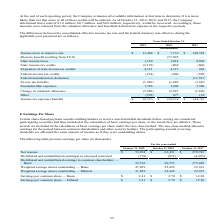From Sanderson Farms's financial document, What is the Income taxes at statutory rate for fiscal years 2019 and 2018 respectively? The document shows two values: $13,408 and $ 7,132 (in thousands). From the document: "Income taxes at statutory rate $ 13,408 $ 7,132 $ 148,585 Income taxes at statutory rate $ 13,408 $ 7,132 $ 148,585..." Also, What is the State income taxes for fiscal years 2019 and 2018 respectively? The document shows two values: 1,189 and 1,014 (in thousands). From the document: "State income taxes 1,189 1,014 9,038 State income taxes 1,189 1,014 9,038..." Also, How much credits would be recovered for 2019, 2018 and 2017 respectively? $1.8 million, $0.7 million, and $0.6 million. The document states: ", and 2017, the Company determined that a total of $1.8 million, $0.7 million, and $0.6 million, respectively, would be recovered. Accordingly, those ..." Also, can you calculate: What is the average Income taxes at statutory rate for fiscal years 2019 and 2018? To answer this question, I need to perform calculations using the financial data. The calculation is: (13,408+ 7,132)/2, which equals 10270 (in thousands). This is based on the information: "Income taxes at statutory rate $ 13,408 $ 7,132 $ 148,585 Income taxes at statutory rate $ 13,408 $ 7,132 $ 148,585..." The key data points involved are: 13,408, 7,132. Also, can you calculate: What is the average state income taxes for fiscal years 2019 and 2018? To answer this question, I need to perform calculations using the financial data. The calculation is: (1,189+1,014)/2, which equals 1101.5 (in thousands). This is based on the information: "State income taxes 1,189 1,014 9,038 State income taxes 1,189 1,014 9,038..." The key data points involved are: 1,014, 1,189. Also, can you calculate: What is the change in Income taxes at statutory rate between fiscal years 2019 and 2018? Based on the calculation: 13,408-7,132, the result is 6276 (in thousands). This is based on the information: "Income taxes at statutory rate $ 13,408 $ 7,132 $ 148,585 Income taxes at statutory rate $ 13,408 $ 7,132 $ 148,585..." The key data points involved are: 13,408, 7,132. 